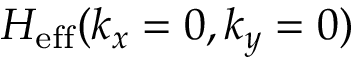Convert formula to latex. <formula><loc_0><loc_0><loc_500><loc_500>H _ { e f f } ( k _ { x } = 0 , k _ { y } = 0 )</formula> 